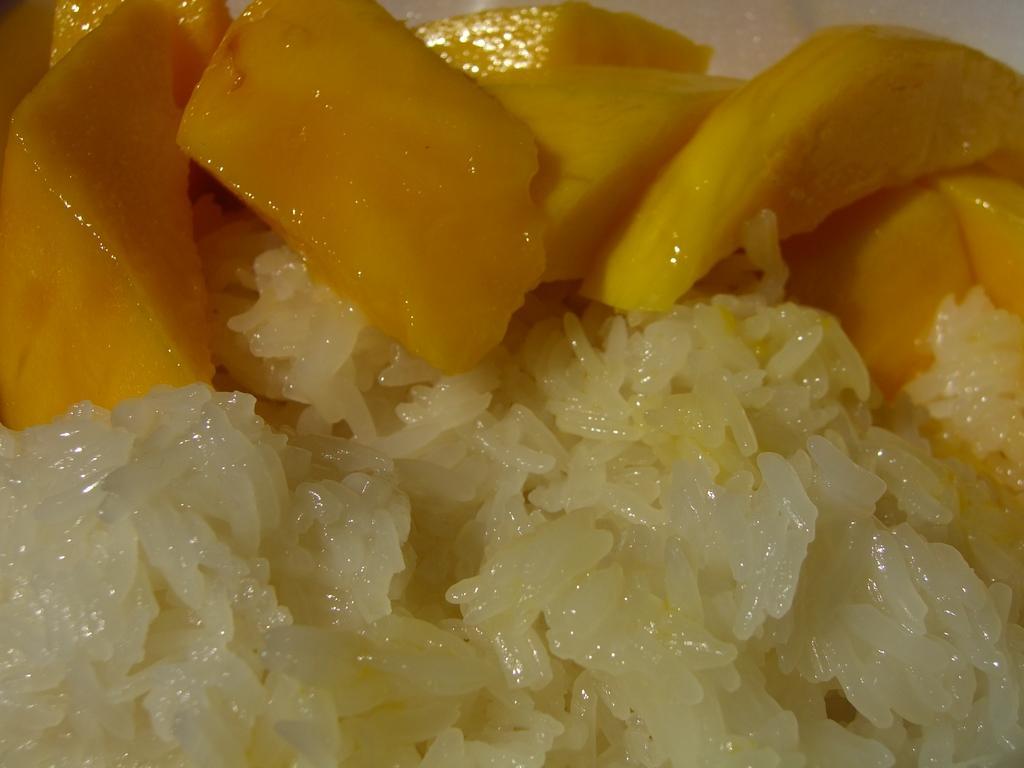Can you describe this image briefly? In this picture we can see food and fruits. 